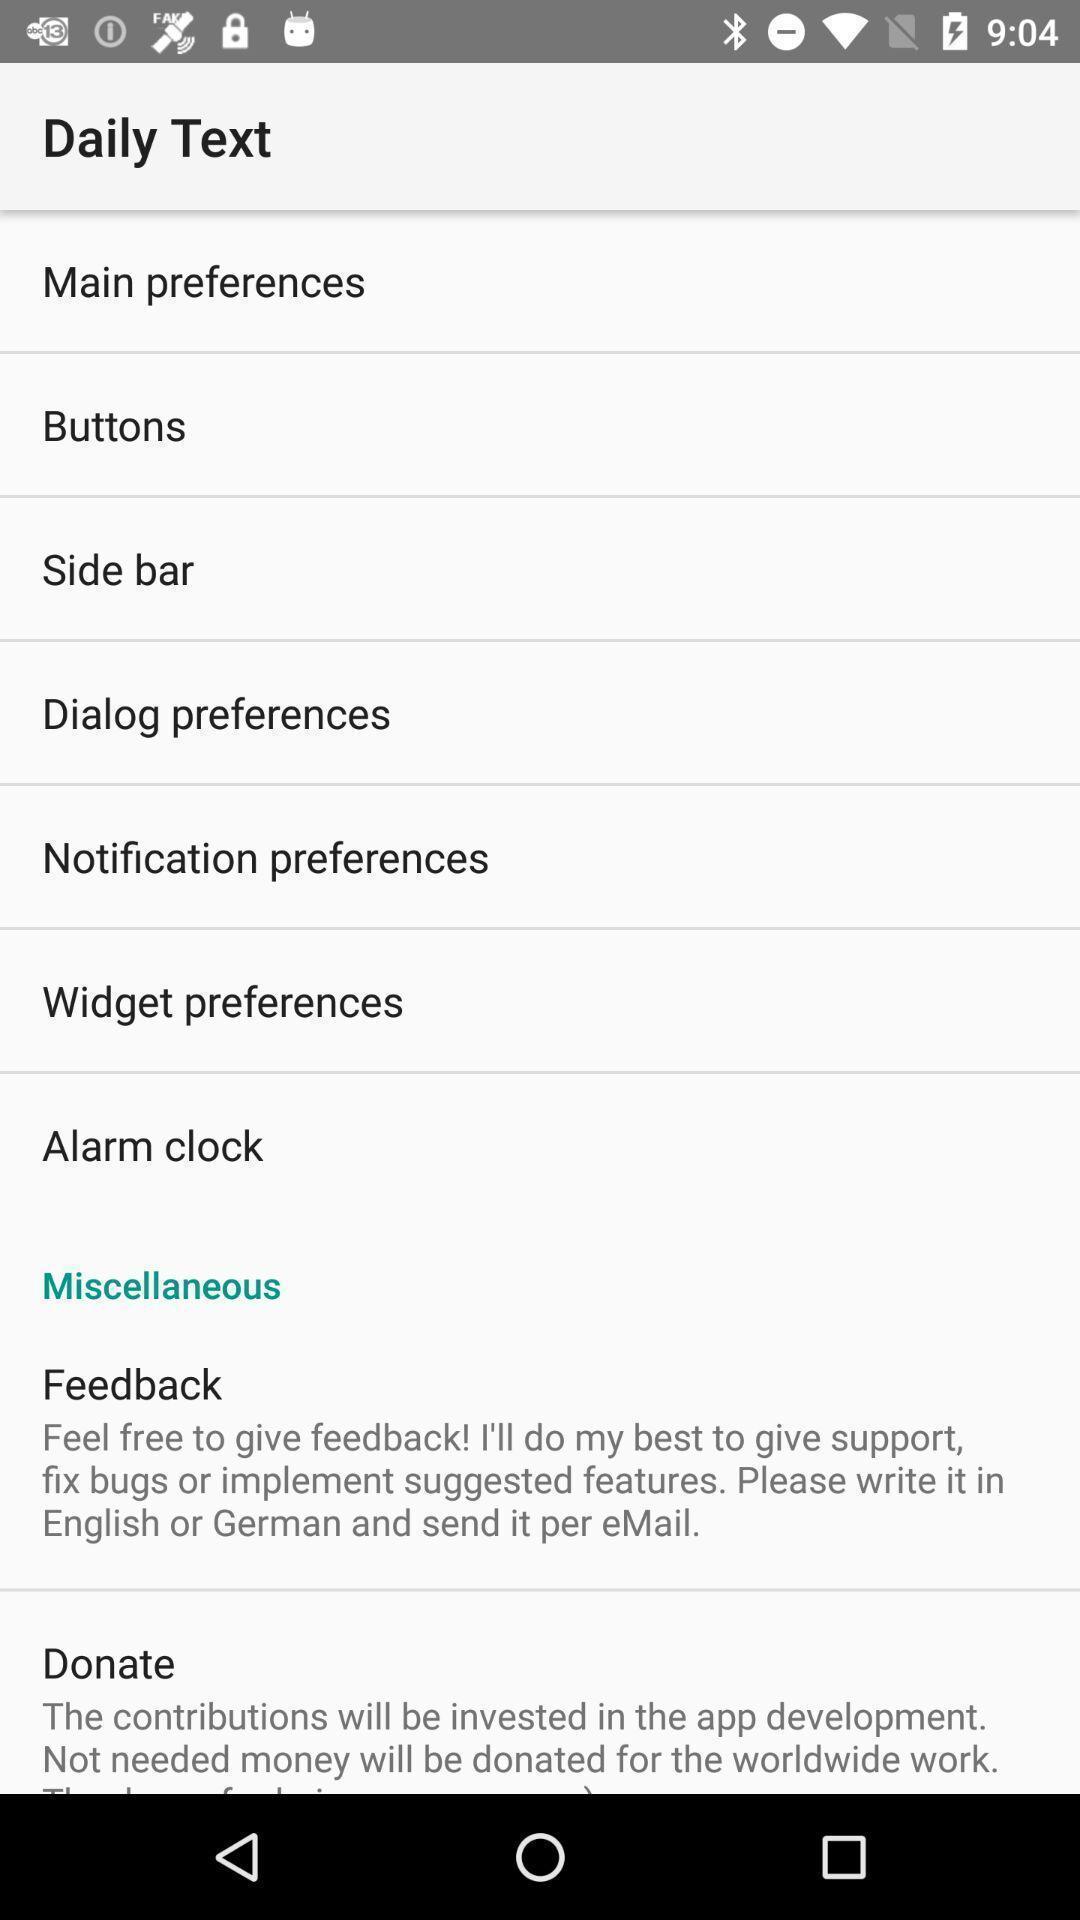Tell me about the visual elements in this screen capture. Various preference options displayed of a communications app. 